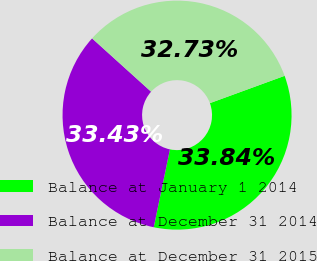Convert chart. <chart><loc_0><loc_0><loc_500><loc_500><pie_chart><fcel>Balance at January 1 2014<fcel>Balance at December 31 2014<fcel>Balance at December 31 2015<nl><fcel>33.84%<fcel>33.43%<fcel>32.73%<nl></chart> 